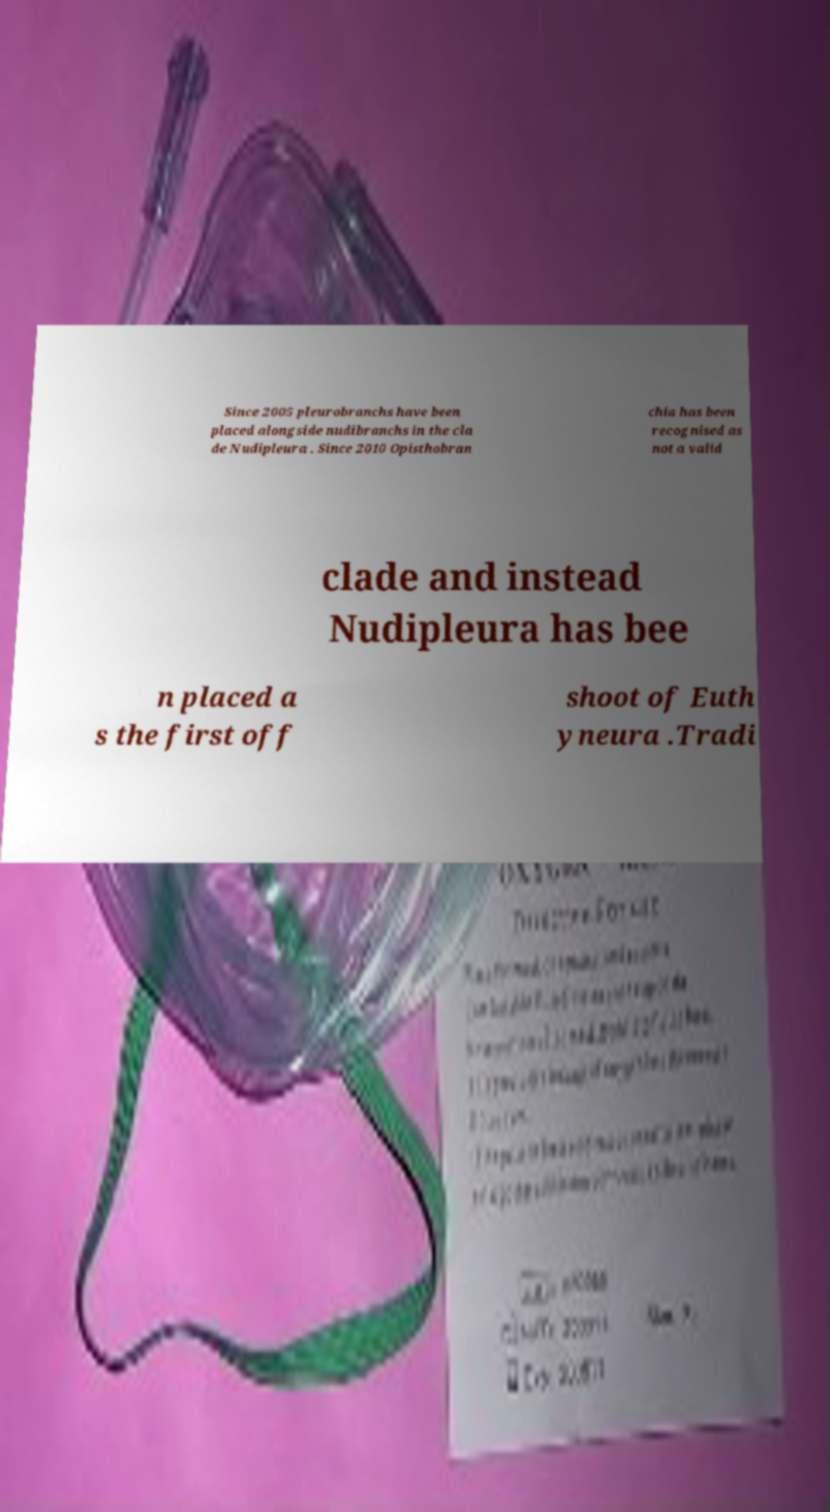Could you extract and type out the text from this image? Since 2005 pleurobranchs have been placed alongside nudibranchs in the cla de Nudipleura . Since 2010 Opisthobran chia has been recognised as not a valid clade and instead Nudipleura has bee n placed a s the first off shoot of Euth yneura .Tradi 